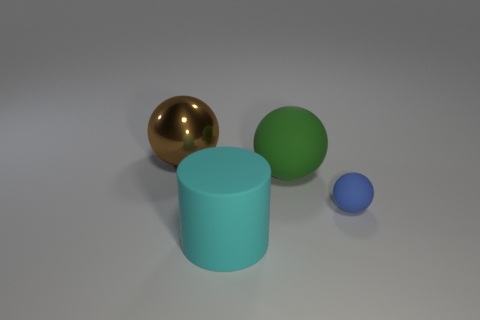Add 4 large red matte blocks. How many objects exist? 8 Subtract all cylinders. How many objects are left? 3 Add 3 big brown balls. How many big brown balls are left? 4 Add 1 small green shiny objects. How many small green shiny objects exist? 1 Subtract 1 cyan cylinders. How many objects are left? 3 Subtract all big metallic things. Subtract all small blue matte things. How many objects are left? 2 